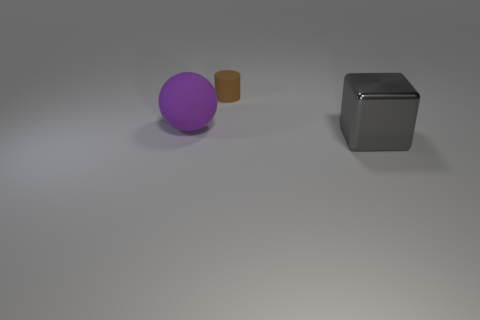How many brown objects are either large rubber things or tiny things?
Offer a very short reply. 1. Are the large purple ball and the object that is behind the purple object made of the same material?
Keep it short and to the point. Yes. Is the number of brown rubber cylinders that are in front of the big purple rubber sphere the same as the number of small rubber cylinders that are behind the matte cylinder?
Give a very brief answer. Yes. There is a brown rubber object; is it the same size as the matte object that is left of the brown rubber cylinder?
Your response must be concise. No. Is the number of shiny objects behind the purple sphere greater than the number of large blue objects?
Offer a very short reply. No. What number of other brown cylinders are the same size as the brown cylinder?
Offer a terse response. 0. Do the purple matte sphere that is in front of the brown rubber cylinder and the thing that is right of the rubber cylinder have the same size?
Provide a short and direct response. Yes. Are there more purple rubber things that are on the right side of the big purple object than spheres in front of the big gray object?
Provide a short and direct response. No. What number of big metal things are the same shape as the big purple matte thing?
Your answer should be very brief. 0. What is the material of the object that is the same size as the metal cube?
Your answer should be compact. Rubber. 